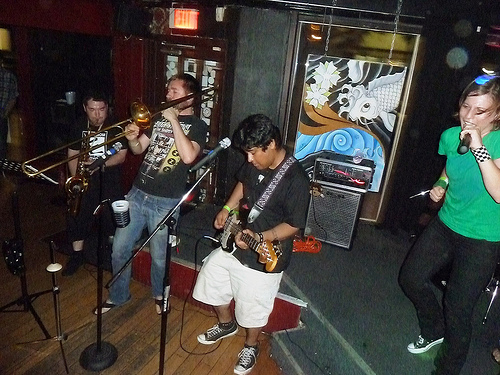<image>
Is the guitar on the man? Yes. Looking at the image, I can see the guitar is positioned on top of the man, with the man providing support. Is there a guitar on the floor? No. The guitar is not positioned on the floor. They may be near each other, but the guitar is not supported by or resting on top of the floor. 